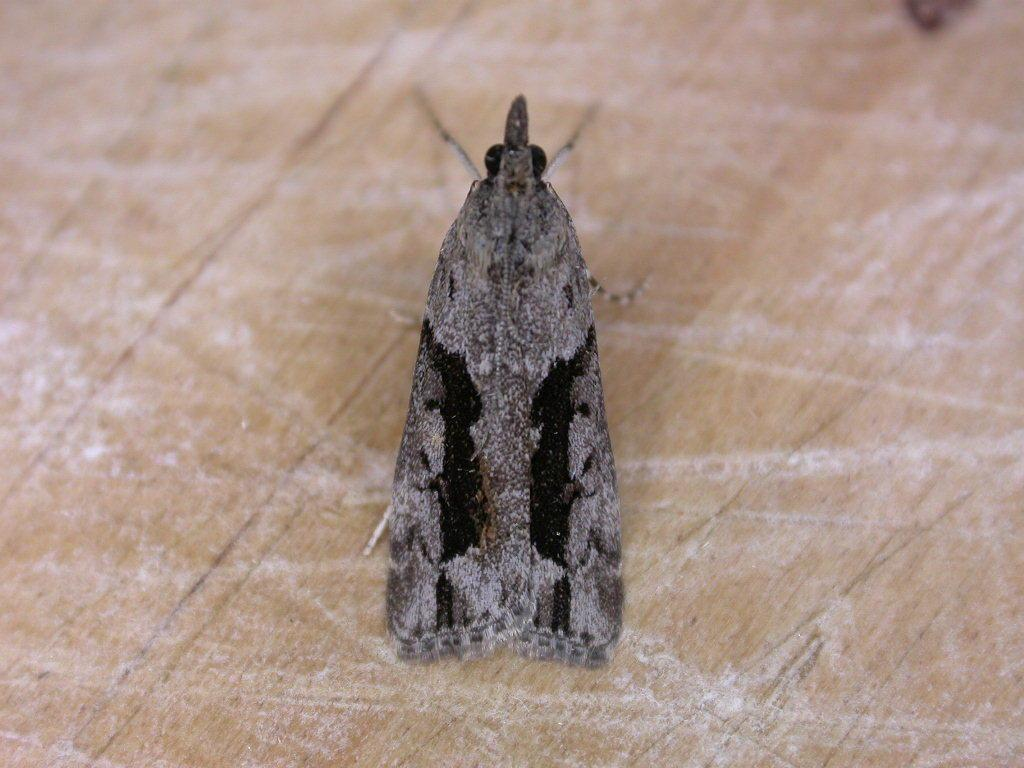What type of creature can be seen in the image? There is an insect in the image. What is the insect resting on in the image? The insect is on a wooden surface. What type of jewel is the insect wearing in the image? There is no jewel present in the image, nor is the insect wearing any jewelry. 